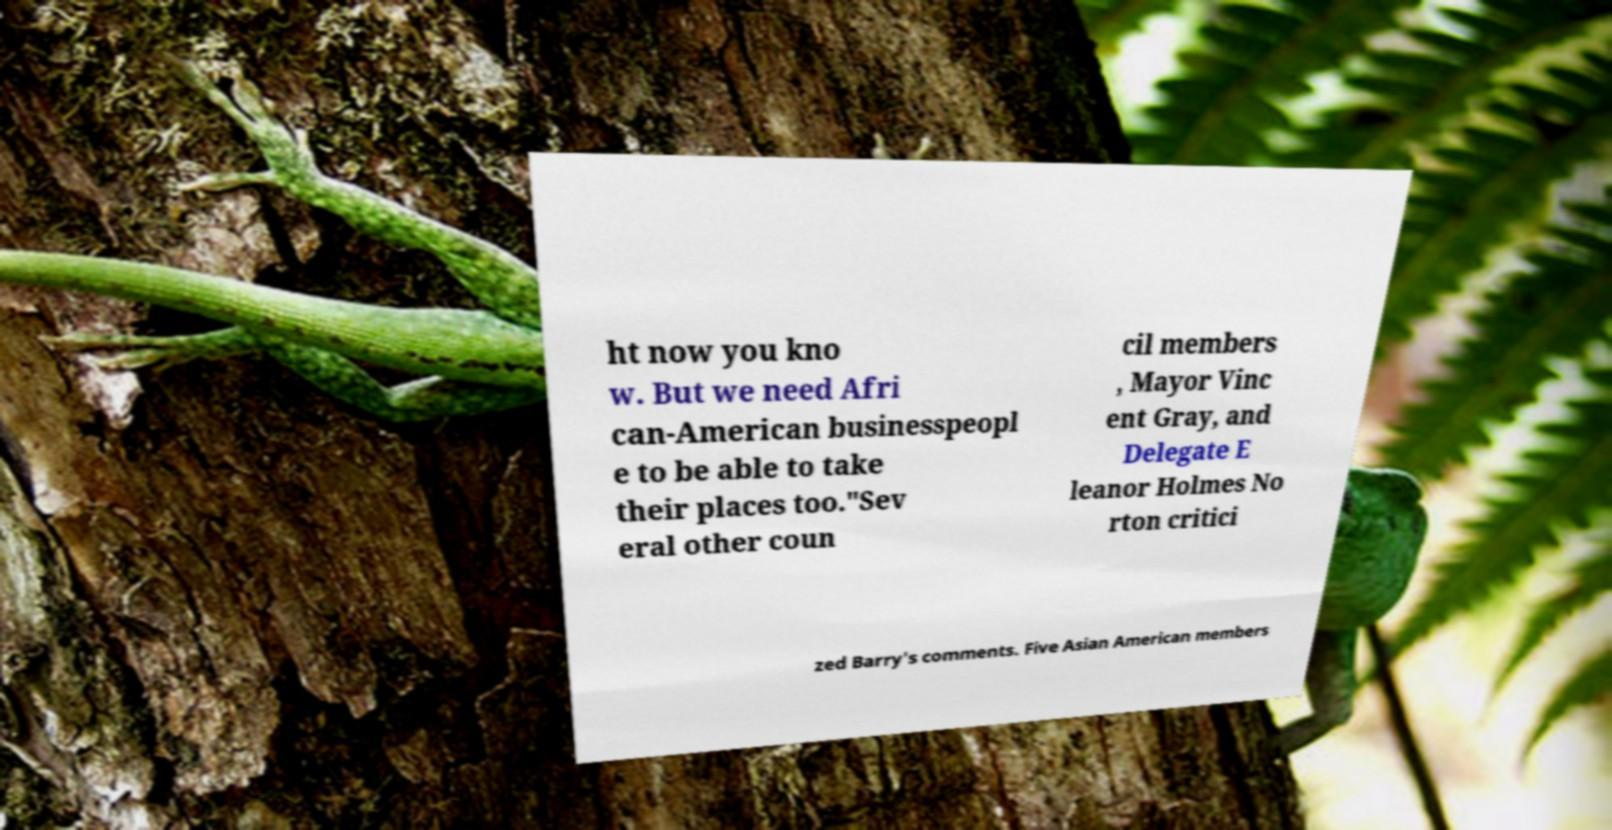Could you assist in decoding the text presented in this image and type it out clearly? ht now you kno w. But we need Afri can-American businesspeopl e to be able to take their places too."Sev eral other coun cil members , Mayor Vinc ent Gray, and Delegate E leanor Holmes No rton critici zed Barry's comments. Five Asian American members 